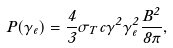Convert formula to latex. <formula><loc_0><loc_0><loc_500><loc_500>P ( \gamma _ { e } ) = \frac { 4 } { 3 } \sigma _ { T } c \gamma ^ { 2 } \gamma _ { e } ^ { 2 } \frac { B ^ { 2 } } { 8 \pi } ,</formula> 